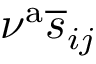<formula> <loc_0><loc_0><loc_500><loc_500>\nu ^ { a } \overline { s } _ { i j }</formula> 